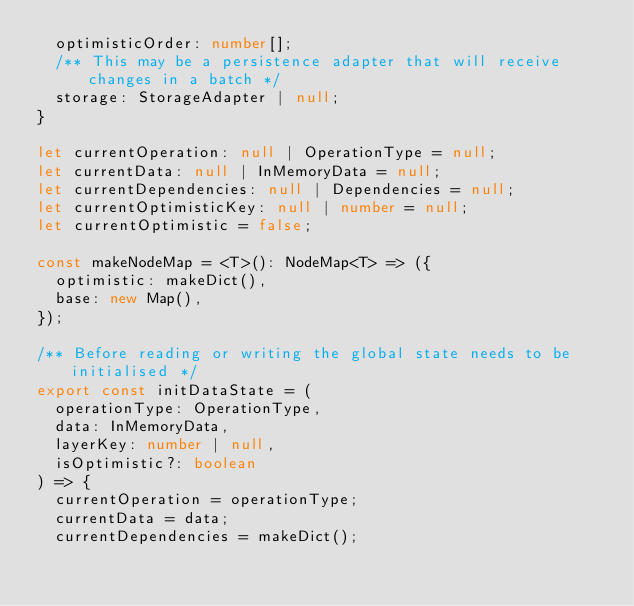Convert code to text. <code><loc_0><loc_0><loc_500><loc_500><_TypeScript_>  optimisticOrder: number[];
  /** This may be a persistence adapter that will receive changes in a batch */
  storage: StorageAdapter | null;
}

let currentOperation: null | OperationType = null;
let currentData: null | InMemoryData = null;
let currentDependencies: null | Dependencies = null;
let currentOptimisticKey: null | number = null;
let currentOptimistic = false;

const makeNodeMap = <T>(): NodeMap<T> => ({
  optimistic: makeDict(),
  base: new Map(),
});

/** Before reading or writing the global state needs to be initialised */
export const initDataState = (
  operationType: OperationType,
  data: InMemoryData,
  layerKey: number | null,
  isOptimistic?: boolean
) => {
  currentOperation = operationType;
  currentData = data;
  currentDependencies = makeDict();</code> 